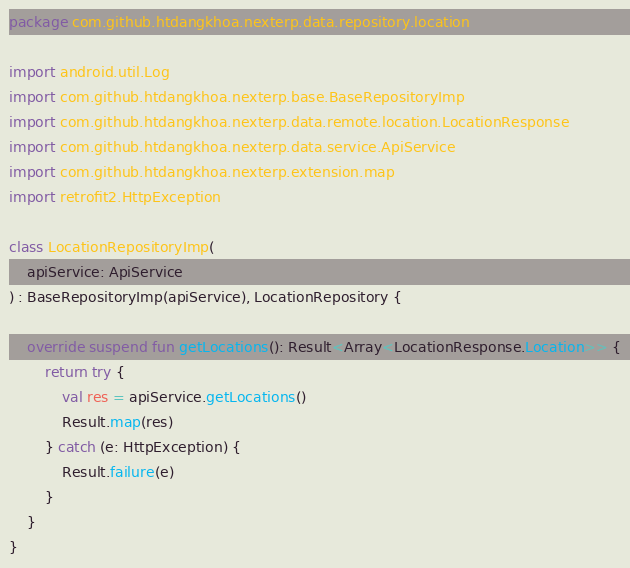Convert code to text. <code><loc_0><loc_0><loc_500><loc_500><_Kotlin_>package com.github.htdangkhoa.nexterp.data.repository.location

import android.util.Log
import com.github.htdangkhoa.nexterp.base.BaseRepositoryImp
import com.github.htdangkhoa.nexterp.data.remote.location.LocationResponse
import com.github.htdangkhoa.nexterp.data.service.ApiService
import com.github.htdangkhoa.nexterp.extension.map
import retrofit2.HttpException

class LocationRepositoryImp(
    apiService: ApiService
) : BaseRepositoryImp(apiService), LocationRepository {

    override suspend fun getLocations(): Result<Array<LocationResponse.Location>> {
        return try {
            val res = apiService.getLocations()
            Result.map(res)
        } catch (e: HttpException) {
            Result.failure(e)
        }
    }
}
</code> 